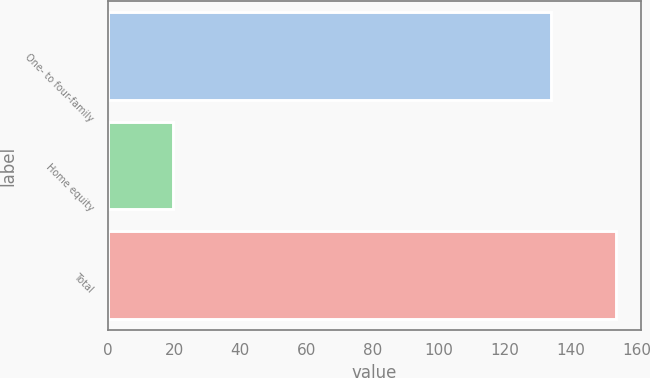Convert chart to OTSL. <chart><loc_0><loc_0><loc_500><loc_500><bar_chart><fcel>One- to four-family<fcel>Home equity<fcel>Total<nl><fcel>134.1<fcel>19.6<fcel>153.7<nl></chart> 